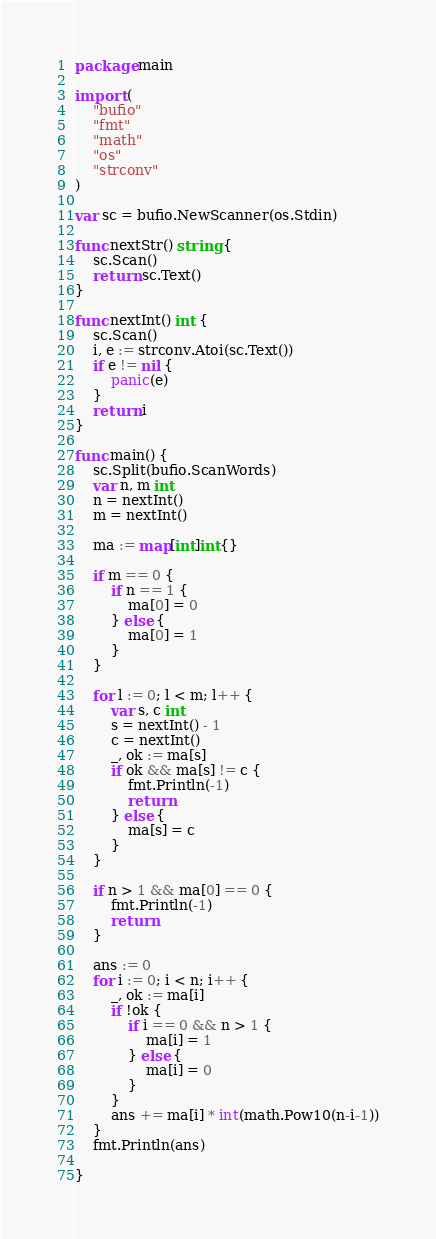Convert code to text. <code><loc_0><loc_0><loc_500><loc_500><_Go_>package main

import (
	"bufio"
	"fmt"
	"math"
	"os"
	"strconv"
)

var sc = bufio.NewScanner(os.Stdin)

func nextStr() string {
	sc.Scan()
	return sc.Text()
}

func nextInt() int {
	sc.Scan()
	i, e := strconv.Atoi(sc.Text())
	if e != nil {
		panic(e)
	}
	return i
}

func main() {
	sc.Split(bufio.ScanWords)
	var n, m int
	n = nextInt()
	m = nextInt()

	ma := map[int]int{}

	if m == 0 {
		if n == 1 {
			ma[0] = 0
		} else {
			ma[0] = 1
		}
	}

	for l := 0; l < m; l++ {
		var s, c int
		s = nextInt() - 1
		c = nextInt()
		_, ok := ma[s]
		if ok && ma[s] != c {
			fmt.Println(-1)
			return
		} else {
			ma[s] = c
		}
	}

	if n > 1 && ma[0] == 0 {
		fmt.Println(-1)
		return
	}

	ans := 0
	for i := 0; i < n; i++ {
		_, ok := ma[i]
		if !ok {
			if i == 0 && n > 1 {
				ma[i] = 1
			} else {
				ma[i] = 0
			}
		}
		ans += ma[i] * int(math.Pow10(n-i-1))
	}
	fmt.Println(ans)

}
</code> 